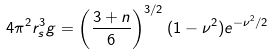Convert formula to latex. <formula><loc_0><loc_0><loc_500><loc_500>4 \pi ^ { 2 } r _ { s } ^ { 3 } g = \left ( \frac { 3 + n } { 6 } \right ) ^ { 3 / 2 } ( 1 - \nu ^ { 2 } ) e ^ { - \nu ^ { 2 } / 2 }</formula> 